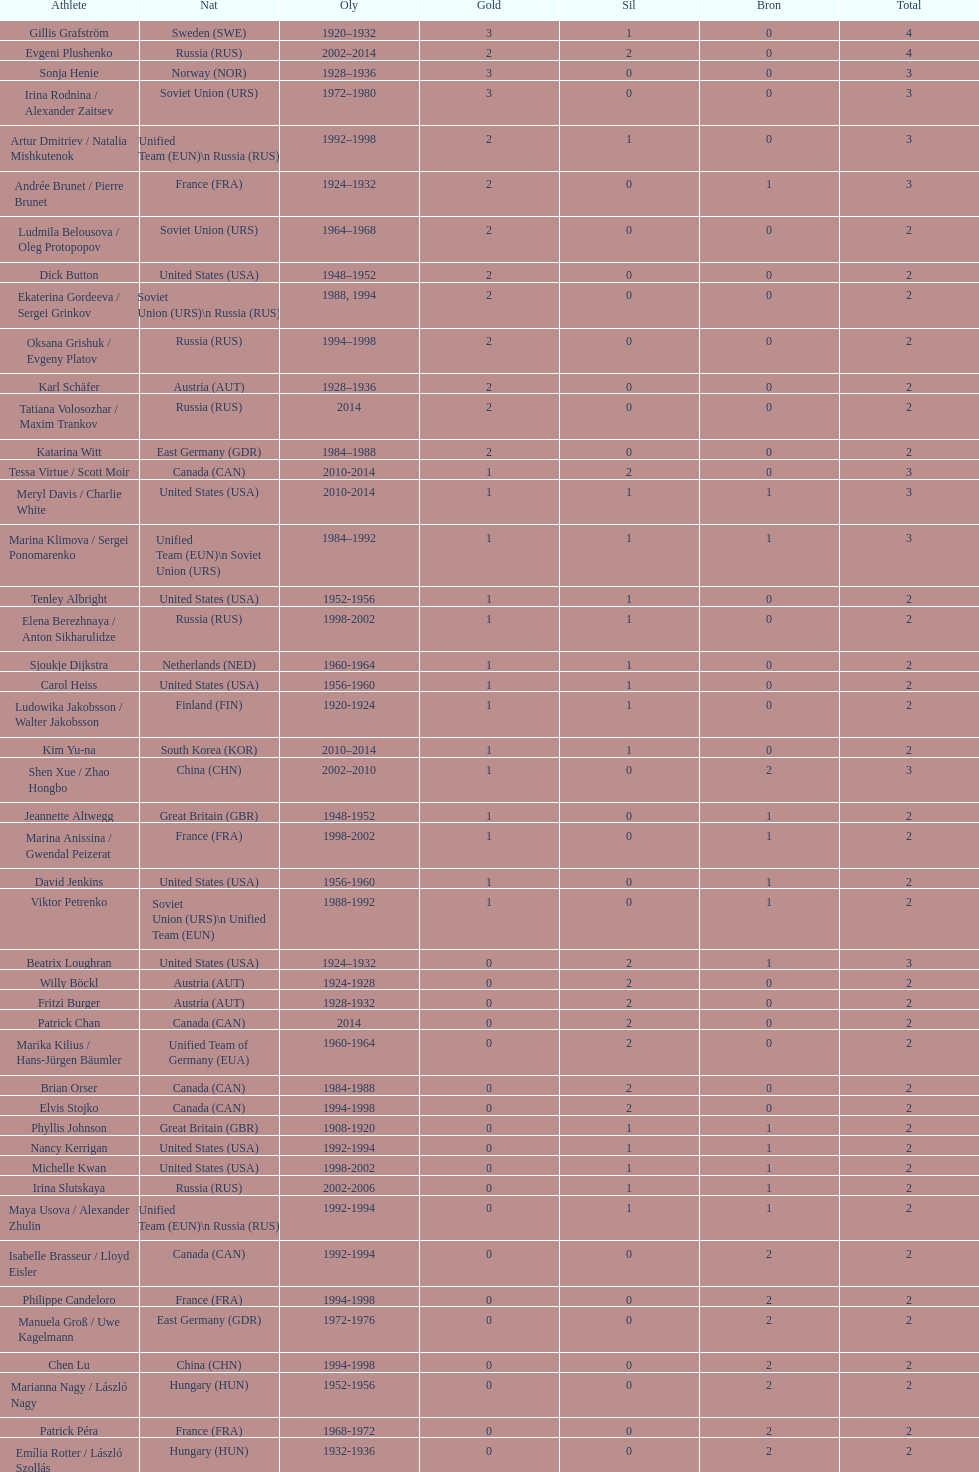Which nation was the first to win three gold medals for olympic figure skating? Sweden. 